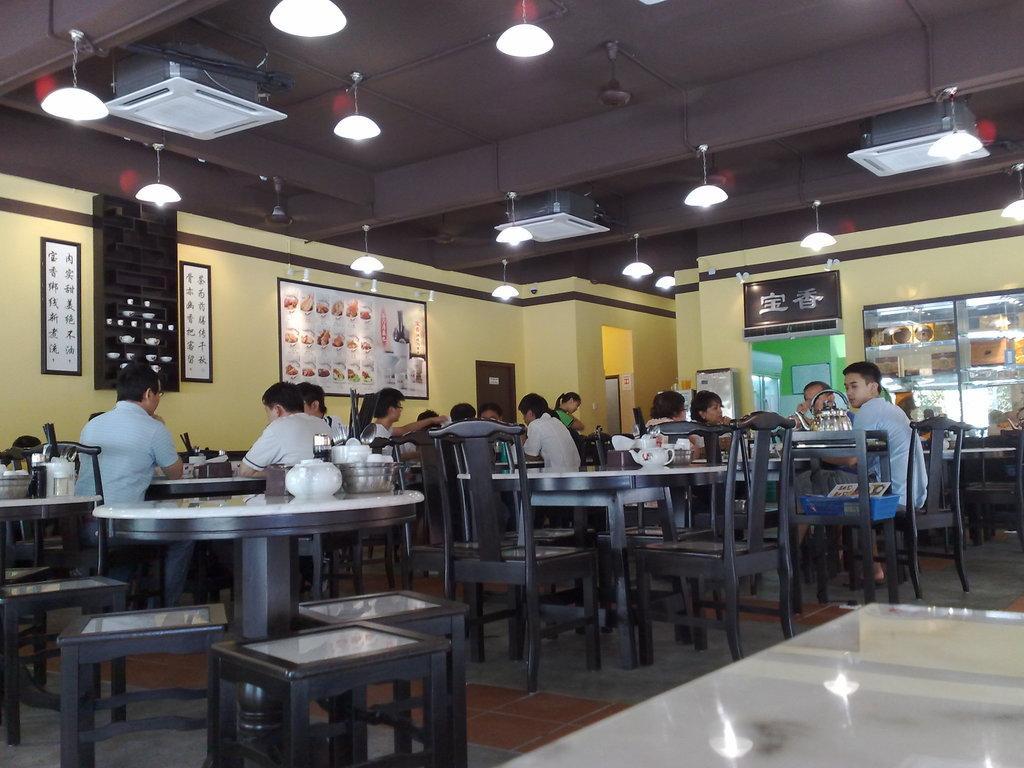Describe this image in one or two sentences. This picture describes about group of people they are all seated on the chair, in front of them we can see bowls on the table, and also we can see wall paintings on the wall. On top of them we can see couple of lights and air conditioners. 